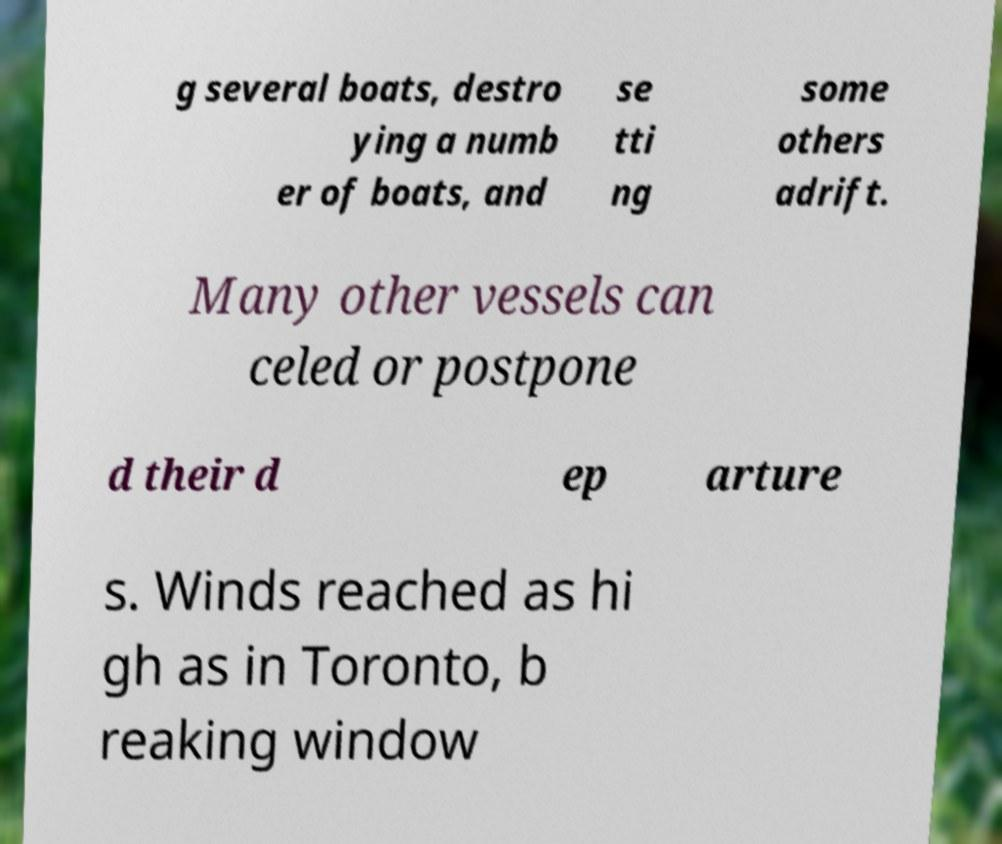I need the written content from this picture converted into text. Can you do that? g several boats, destro ying a numb er of boats, and se tti ng some others adrift. Many other vessels can celed or postpone d their d ep arture s. Winds reached as hi gh as in Toronto, b reaking window 